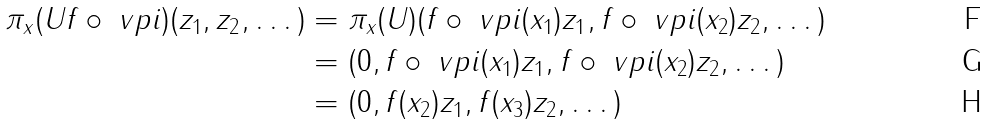Convert formula to latex. <formula><loc_0><loc_0><loc_500><loc_500>\pi _ { x } ( U f \circ \ v p i ) ( z _ { 1 } , z _ { 2 } , \dots ) & = \pi _ { x } ( U ) ( f \circ \ v p i ( x _ { 1 } ) z _ { 1 } , f \circ \ v p i ( x _ { 2 } ) z _ { 2 } , \dots ) \\ & = ( 0 , f \circ \ v p i ( x _ { 1 } ) z _ { 1 } , f \circ \ v p i ( x _ { 2 } ) z _ { 2 } , \dots ) \\ & = ( 0 , f ( x _ { 2 } ) z _ { 1 } , f ( x _ { 3 } ) z _ { 2 } , \dots )</formula> 